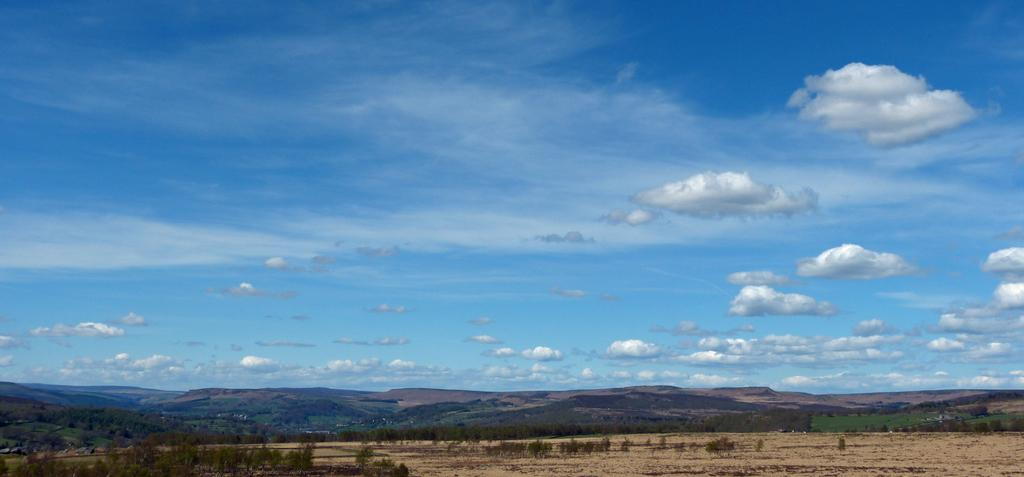What type of natural landscape is depicted in the image? The image features mountains. What other natural elements can be seen in the image? There are trees and plants in the image. What is visible in the sky in the image? There are clouds in the sky in the image. What type of comfort can be found in the image? There is no reference to comfort in the image, as it features natural landscapes and elements. 